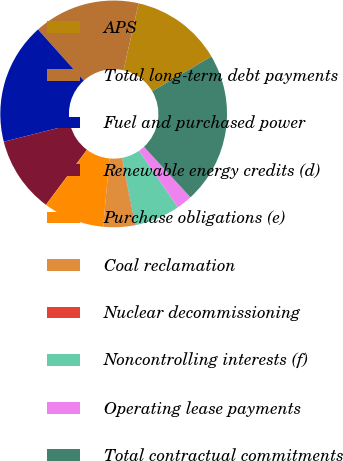<chart> <loc_0><loc_0><loc_500><loc_500><pie_chart><fcel>APS<fcel>Total long-term debt payments<fcel>Fuel and purchased power<fcel>Renewable energy credits (d)<fcel>Purchase obligations (e)<fcel>Coal reclamation<fcel>Nuclear decommissioning<fcel>Noncontrolling interests (f)<fcel>Operating lease payments<fcel>Total contractual commitments<nl><fcel>13.01%<fcel>15.16%<fcel>17.32%<fcel>10.86%<fcel>8.71%<fcel>4.41%<fcel>0.1%<fcel>6.56%<fcel>2.25%<fcel>21.62%<nl></chart> 